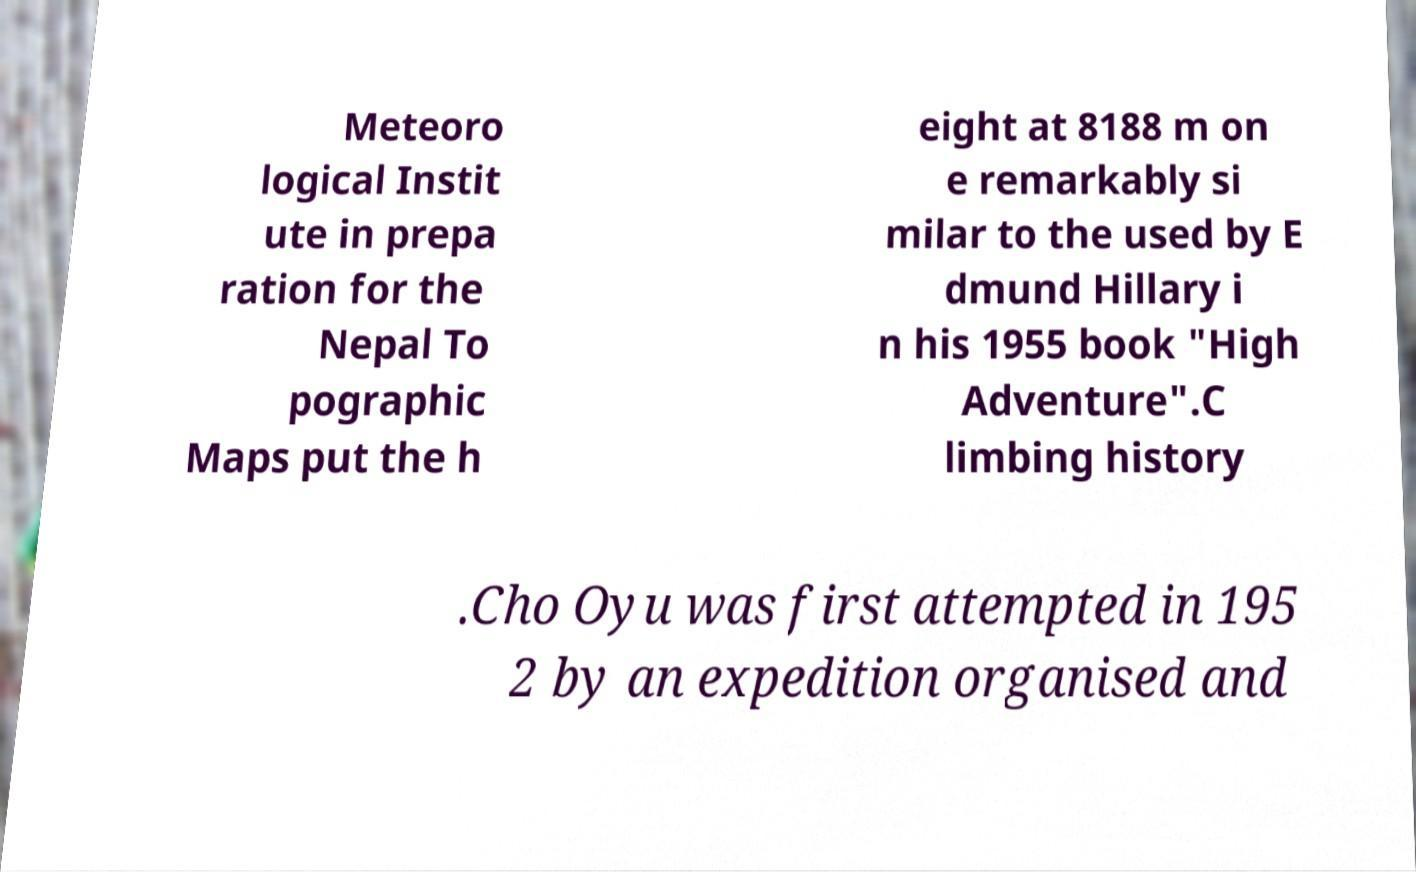Could you assist in decoding the text presented in this image and type it out clearly? Meteoro logical Instit ute in prepa ration for the Nepal To pographic Maps put the h eight at 8188 m on e remarkably si milar to the used by E dmund Hillary i n his 1955 book "High Adventure".C limbing history .Cho Oyu was first attempted in 195 2 by an expedition organised and 